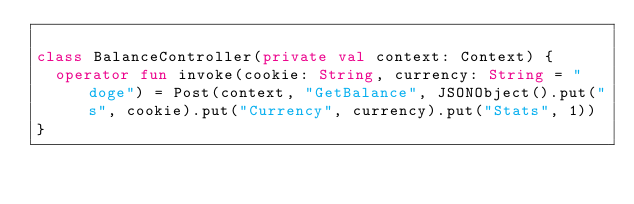Convert code to text. <code><loc_0><loc_0><loc_500><loc_500><_Kotlin_>
class BalanceController(private val context: Context) {
  operator fun invoke(cookie: String, currency: String = "doge") = Post(context, "GetBalance", JSONObject().put("s", cookie).put("Currency", currency).put("Stats", 1))
}</code> 